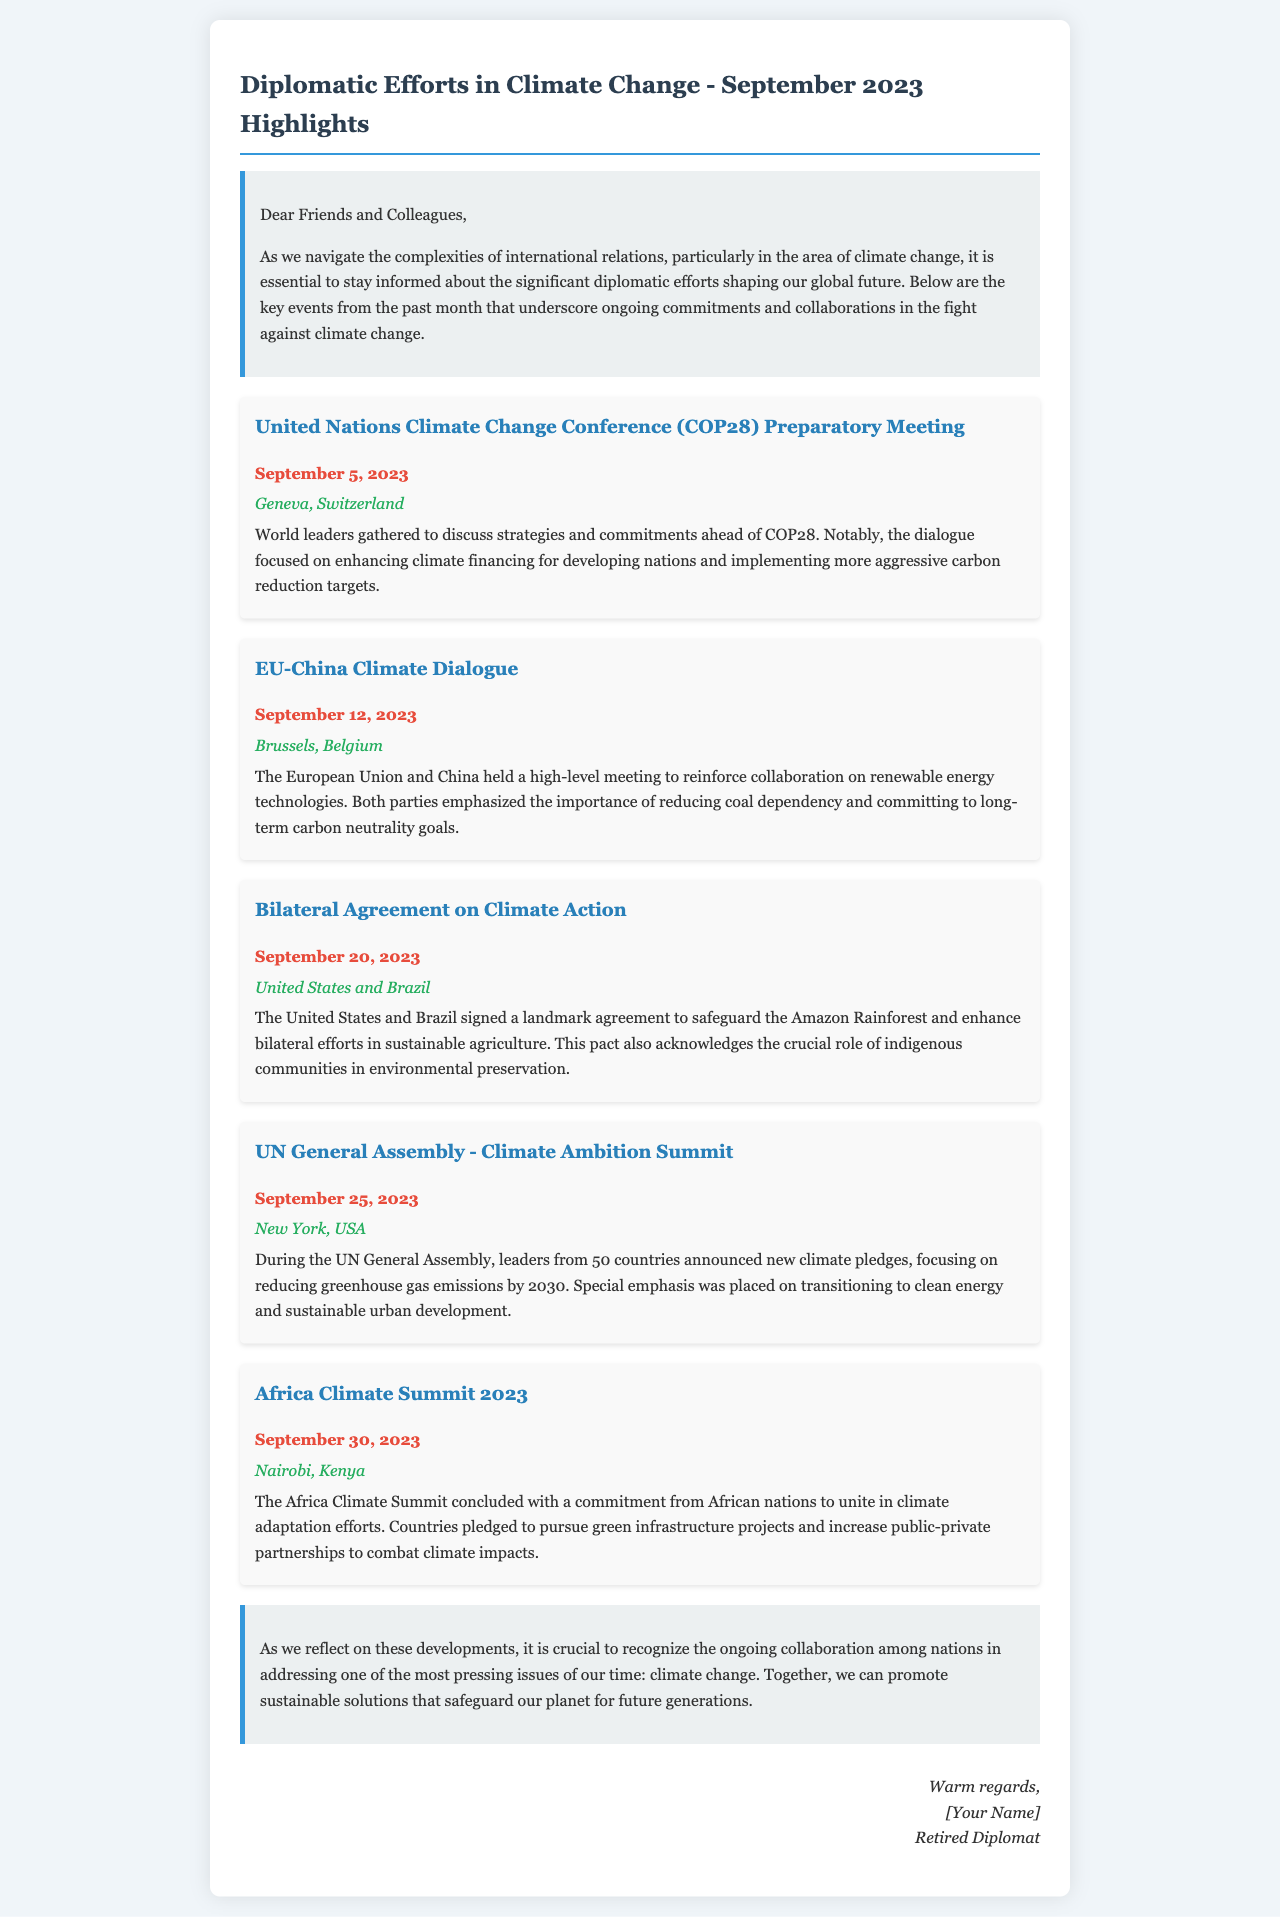What was the date of the COP28 preparatory meeting? The document provides the specific date when the COP28 preparatory meeting occurred, which is September 5, 2023.
Answer: September 5, 2023 Where did the EU-China Climate Dialogue take place? The document states the location of the EU-China Climate Dialogue meeting, which is Brussels, Belgium.
Answer: Brussels, Belgium What significant agreement was signed on September 20, 2023? The document mentions the signing of a bilateral agreement focused on climate action between the United States and Brazil.
Answer: Bilateral Agreement on Climate Action How many countries announced new climate pledges during the UN General Assembly? The document notes that leaders from 50 countries announced new climate pledges during the UN General Assembly.
Answer: 50 What commitment did African nations make at the Africa Climate Summit? The document outlines that African nations committed to unite in climate adaptation efforts during the Africa Climate Summit.
Answer: Unite in climate adaptation efforts What was a key focus of the COP28 preparatory meeting? The document highlights the enhancement of climate financing for developing nations as a significant discussion point during the COP28 preparatory meeting.
Answer: Enhancing climate financing What role did indigenous communities play in the climate action agreement between the U.S. and Brazil? According to the document, the pact acknowledges the crucial role of indigenous communities in environmental preservation.
Answer: Crucial role in environmental preservation What type of document is this? The structure and nature of the content indicate that this is a newsletter summarizing international relations events related to climate change.
Answer: Newsletter 